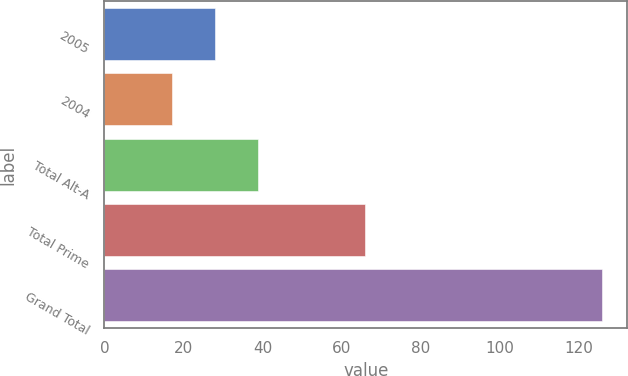Convert chart to OTSL. <chart><loc_0><loc_0><loc_500><loc_500><bar_chart><fcel>2005<fcel>2004<fcel>Total Alt-A<fcel>Total Prime<fcel>Grand Total<nl><fcel>27.9<fcel>17<fcel>38.8<fcel>66<fcel>126<nl></chart> 